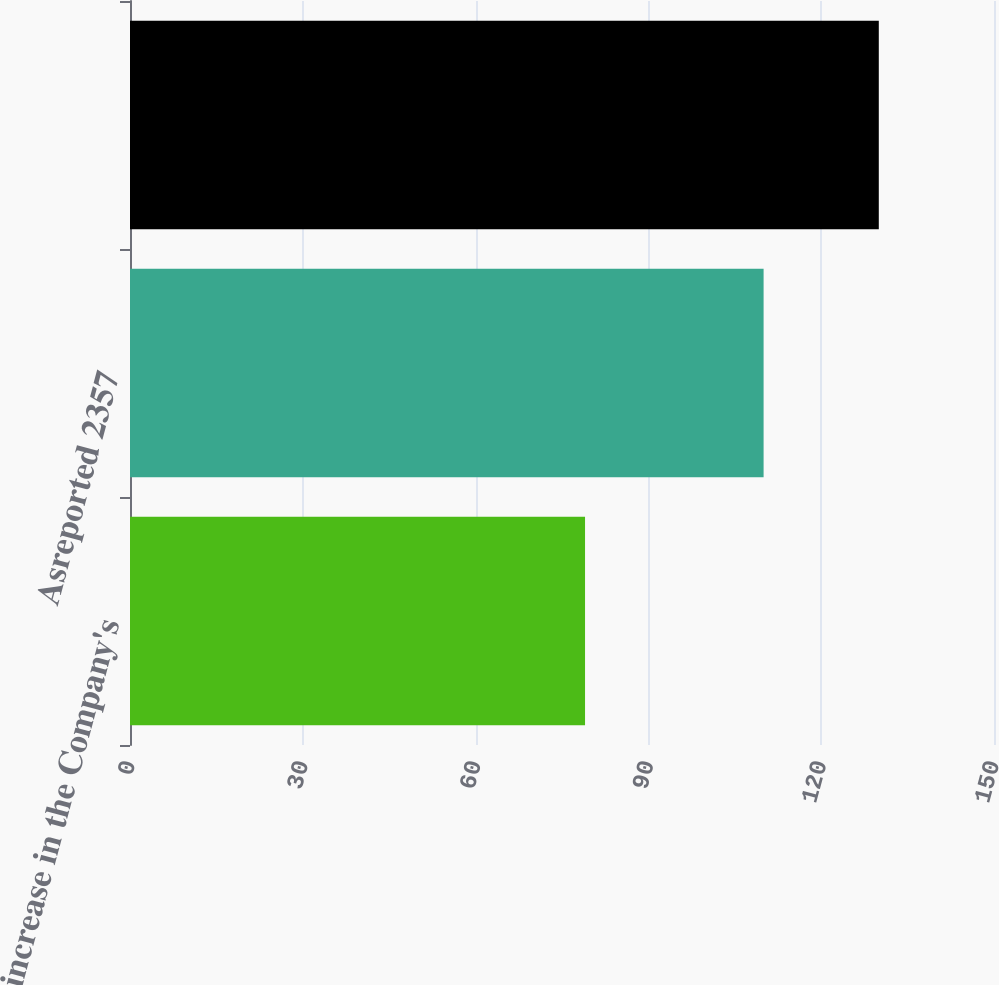<chart> <loc_0><loc_0><loc_500><loc_500><bar_chart><fcel>100 increase in the Company's<fcel>Asreported 2357<fcel>Unnamed: 2<nl><fcel>79<fcel>110<fcel>130<nl></chart> 